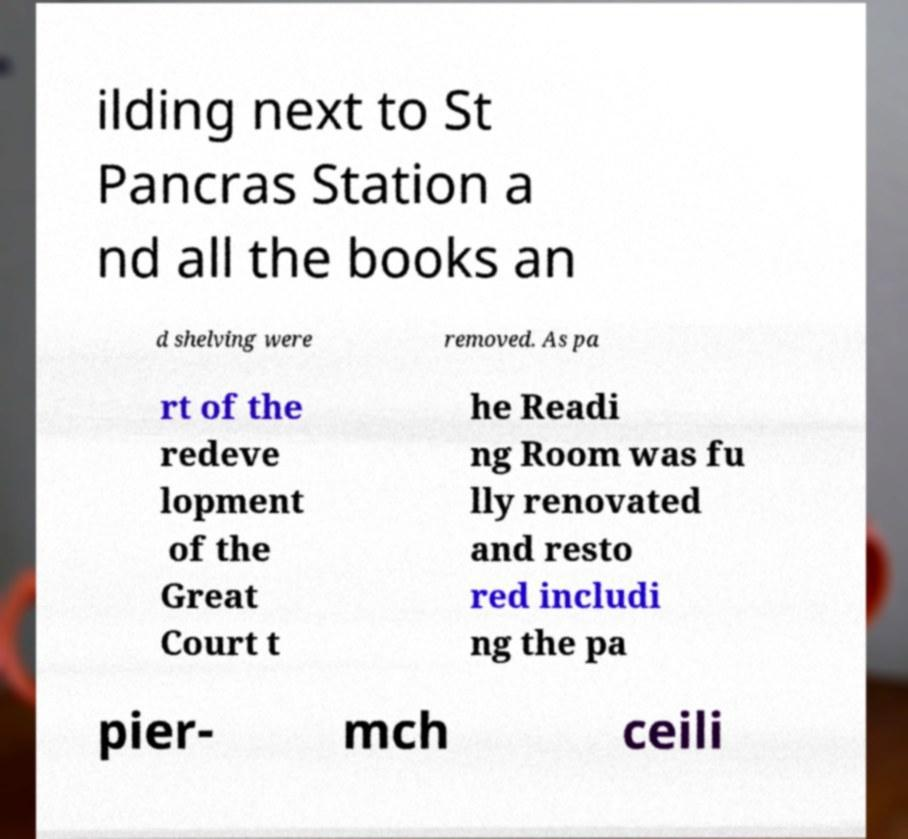For documentation purposes, I need the text within this image transcribed. Could you provide that? ilding next to St Pancras Station a nd all the books an d shelving were removed. As pa rt of the redeve lopment of the Great Court t he Readi ng Room was fu lly renovated and resto red includi ng the pa pier- mch ceili 